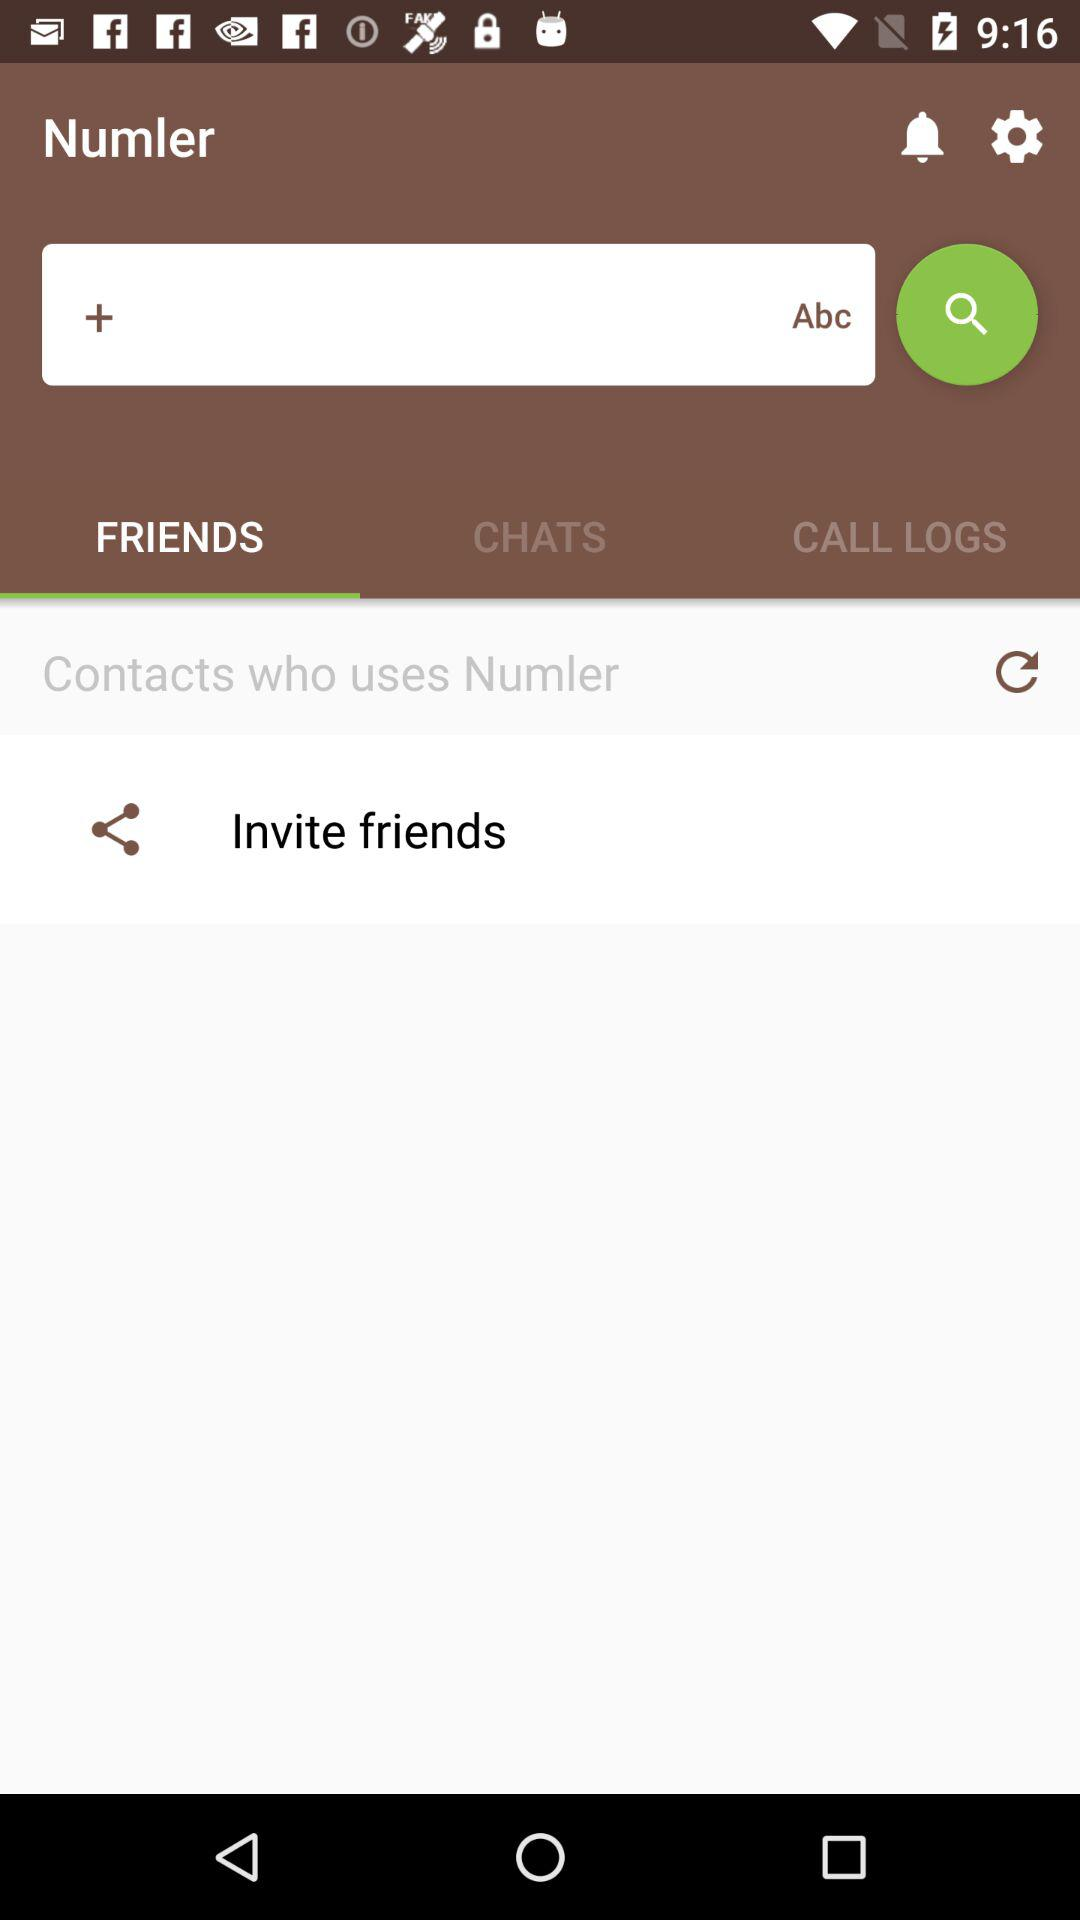Which tab has been selected? The tab "FRIENDS" has been selected. 